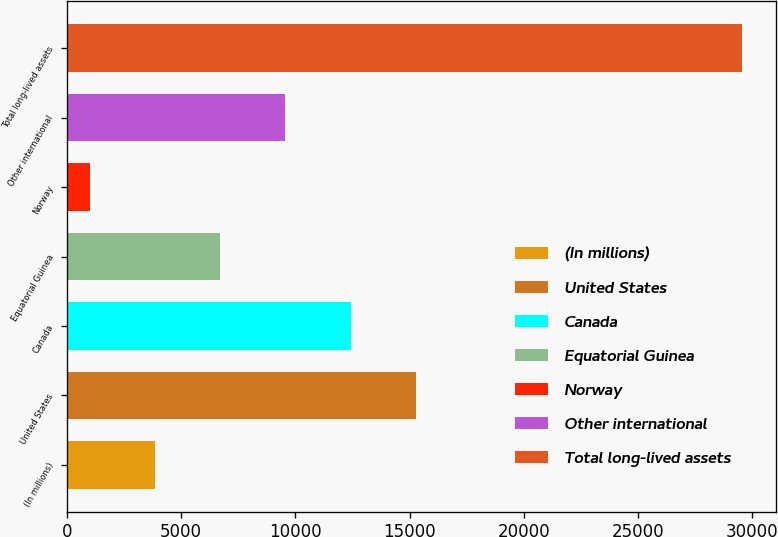Convert chart. <chart><loc_0><loc_0><loc_500><loc_500><bar_chart><fcel>(In millions)<fcel>United States<fcel>Canada<fcel>Equatorial Guinea<fcel>Norway<fcel>Other international<fcel>Total long-lived assets<nl><fcel>3843.4<fcel>15269<fcel>12412.6<fcel>6699.8<fcel>987<fcel>9556.2<fcel>29551<nl></chart> 